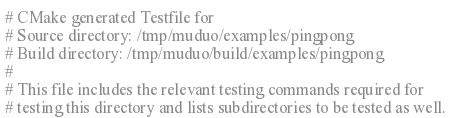Convert code to text. <code><loc_0><loc_0><loc_500><loc_500><_CMake_># CMake generated Testfile for 
# Source directory: /tmp/muduo/examples/pingpong
# Build directory: /tmp/muduo/build/examples/pingpong
# 
# This file includes the relevant testing commands required for 
# testing this directory and lists subdirectories to be tested as well.
</code> 